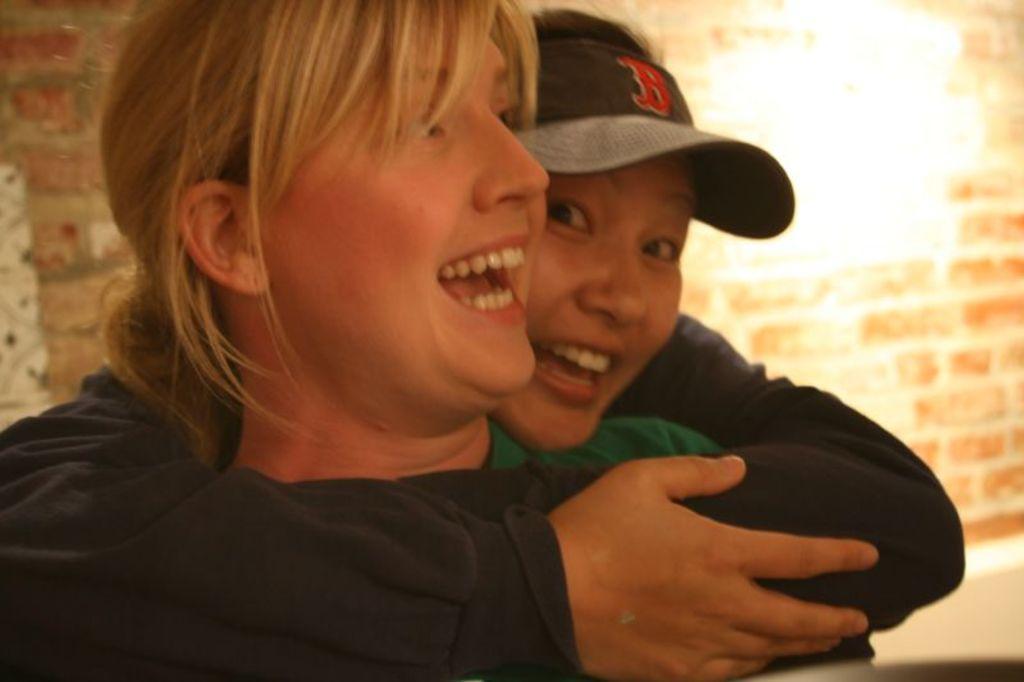How would you summarize this image in a sentence or two? In this image in front there are two people wearing a smile on their faces. In the background of the image there is a brick wall. 